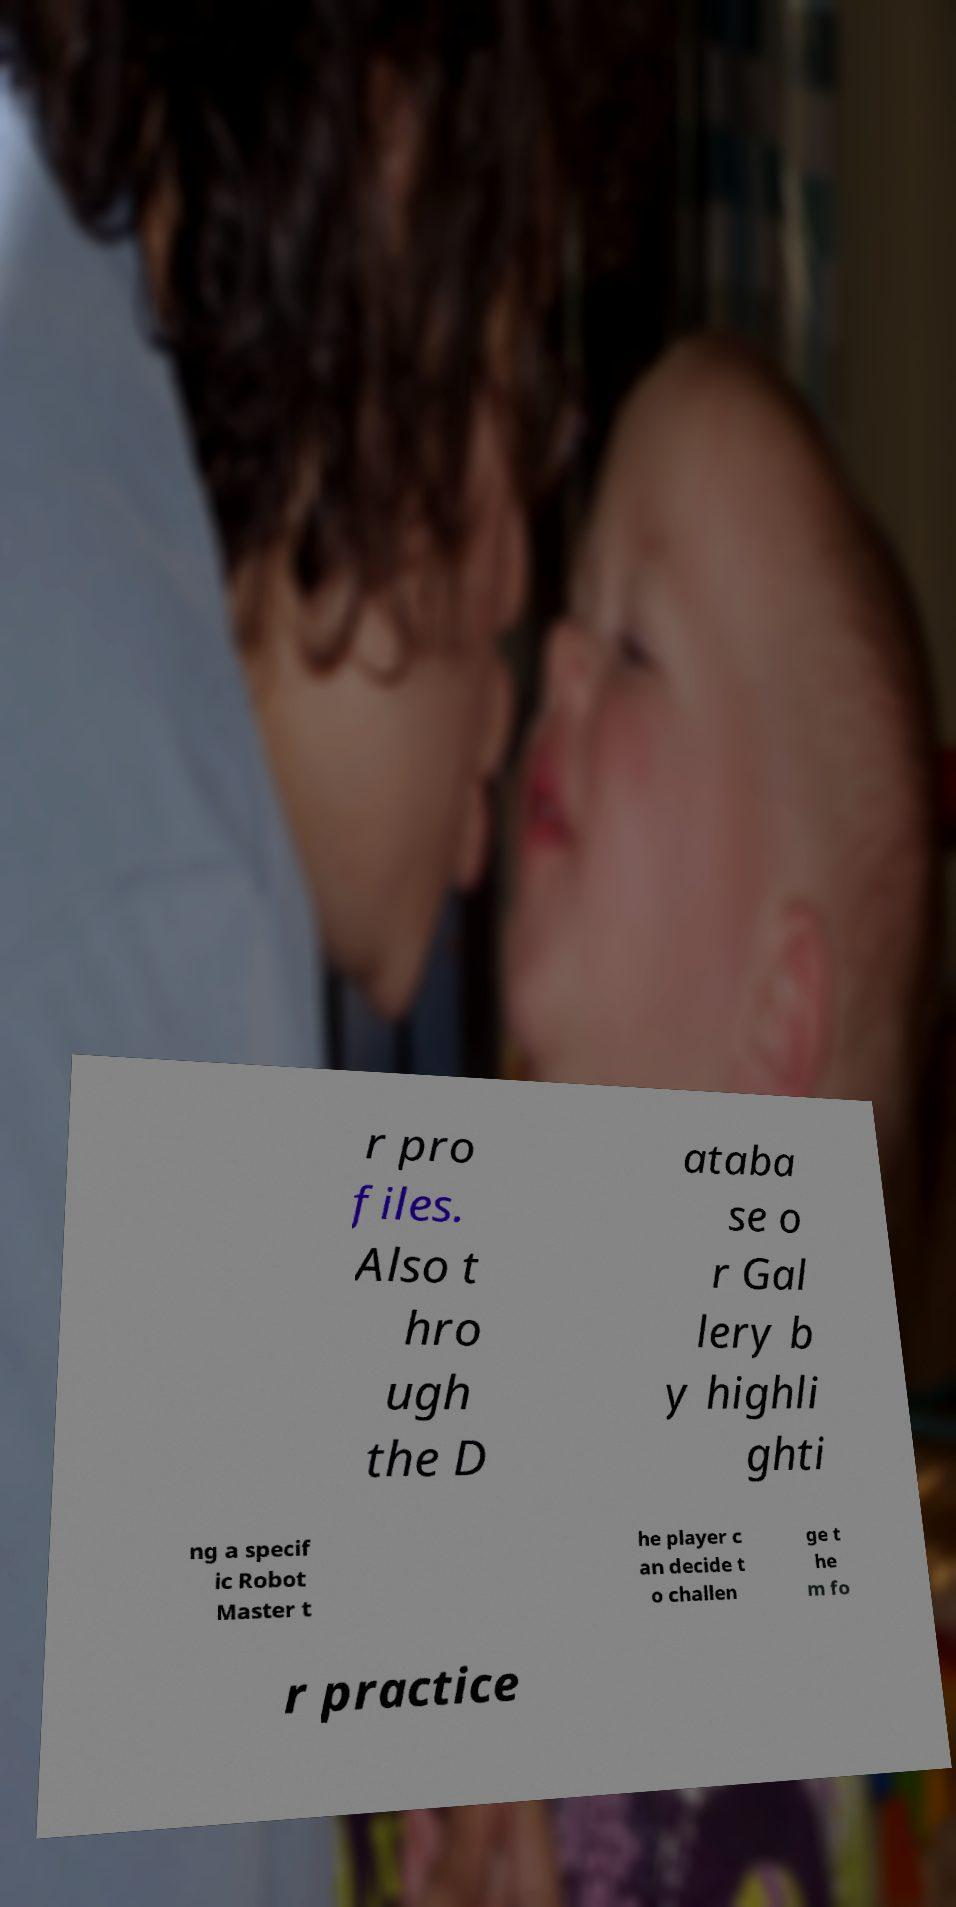Can you read and provide the text displayed in the image?This photo seems to have some interesting text. Can you extract and type it out for me? r pro files. Also t hro ugh the D ataba se o r Gal lery b y highli ghti ng a specif ic Robot Master t he player c an decide t o challen ge t he m fo r practice 